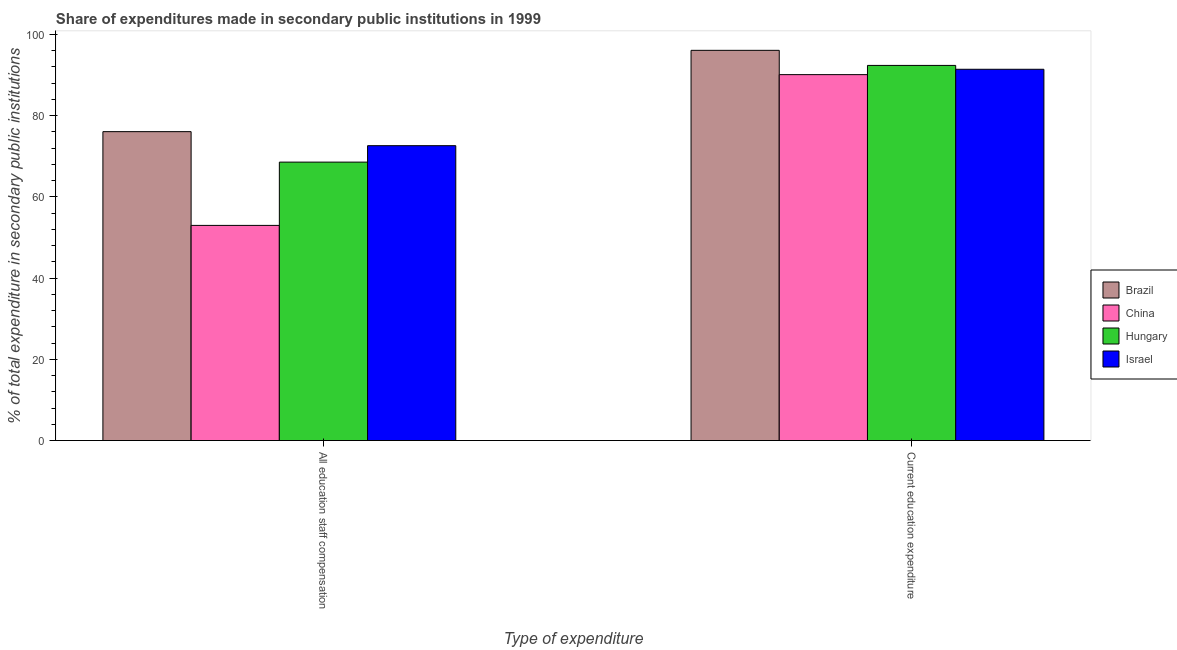How many groups of bars are there?
Your answer should be very brief. 2. How many bars are there on the 2nd tick from the left?
Keep it short and to the point. 4. How many bars are there on the 2nd tick from the right?
Keep it short and to the point. 4. What is the label of the 1st group of bars from the left?
Provide a short and direct response. All education staff compensation. What is the expenditure in education in China?
Provide a succinct answer. 90.11. Across all countries, what is the maximum expenditure in education?
Your answer should be very brief. 96.09. Across all countries, what is the minimum expenditure in education?
Your answer should be compact. 90.11. In which country was the expenditure in staff compensation minimum?
Offer a very short reply. China. What is the total expenditure in staff compensation in the graph?
Provide a short and direct response. 270.23. What is the difference between the expenditure in staff compensation in Israel and that in Brazil?
Make the answer very short. -3.46. What is the difference between the expenditure in staff compensation in Hungary and the expenditure in education in China?
Your answer should be compact. -21.54. What is the average expenditure in staff compensation per country?
Ensure brevity in your answer.  67.56. What is the difference between the expenditure in staff compensation and expenditure in education in Israel?
Offer a very short reply. -18.82. In how many countries, is the expenditure in staff compensation greater than 12 %?
Offer a terse response. 4. What is the ratio of the expenditure in staff compensation in Brazil to that in Hungary?
Your response must be concise. 1.11. What does the 3rd bar from the left in All education staff compensation represents?
Make the answer very short. Hungary. What does the 2nd bar from the right in All education staff compensation represents?
Offer a terse response. Hungary. How many bars are there?
Keep it short and to the point. 8. What is the difference between two consecutive major ticks on the Y-axis?
Provide a succinct answer. 20. Does the graph contain any zero values?
Your response must be concise. No. Where does the legend appear in the graph?
Your response must be concise. Center right. How many legend labels are there?
Make the answer very short. 4. What is the title of the graph?
Provide a succinct answer. Share of expenditures made in secondary public institutions in 1999. What is the label or title of the X-axis?
Offer a very short reply. Type of expenditure. What is the label or title of the Y-axis?
Provide a short and direct response. % of total expenditure in secondary public institutions. What is the % of total expenditure in secondary public institutions in Brazil in All education staff compensation?
Your response must be concise. 76.07. What is the % of total expenditure in secondary public institutions in China in All education staff compensation?
Your response must be concise. 52.98. What is the % of total expenditure in secondary public institutions in Hungary in All education staff compensation?
Offer a terse response. 68.57. What is the % of total expenditure in secondary public institutions of Israel in All education staff compensation?
Your answer should be very brief. 72.61. What is the % of total expenditure in secondary public institutions of Brazil in Current education expenditure?
Offer a very short reply. 96.09. What is the % of total expenditure in secondary public institutions of China in Current education expenditure?
Offer a terse response. 90.11. What is the % of total expenditure in secondary public institutions of Hungary in Current education expenditure?
Give a very brief answer. 92.38. What is the % of total expenditure in secondary public institutions in Israel in Current education expenditure?
Offer a very short reply. 91.43. Across all Type of expenditure, what is the maximum % of total expenditure in secondary public institutions in Brazil?
Give a very brief answer. 96.09. Across all Type of expenditure, what is the maximum % of total expenditure in secondary public institutions of China?
Make the answer very short. 90.11. Across all Type of expenditure, what is the maximum % of total expenditure in secondary public institutions in Hungary?
Your response must be concise. 92.38. Across all Type of expenditure, what is the maximum % of total expenditure in secondary public institutions in Israel?
Your answer should be compact. 91.43. Across all Type of expenditure, what is the minimum % of total expenditure in secondary public institutions of Brazil?
Ensure brevity in your answer.  76.07. Across all Type of expenditure, what is the minimum % of total expenditure in secondary public institutions of China?
Your answer should be very brief. 52.98. Across all Type of expenditure, what is the minimum % of total expenditure in secondary public institutions in Hungary?
Offer a terse response. 68.57. Across all Type of expenditure, what is the minimum % of total expenditure in secondary public institutions in Israel?
Offer a terse response. 72.61. What is the total % of total expenditure in secondary public institutions of Brazil in the graph?
Offer a terse response. 172.16. What is the total % of total expenditure in secondary public institutions in China in the graph?
Your answer should be compact. 143.09. What is the total % of total expenditure in secondary public institutions in Hungary in the graph?
Your answer should be compact. 160.94. What is the total % of total expenditure in secondary public institutions of Israel in the graph?
Keep it short and to the point. 164.04. What is the difference between the % of total expenditure in secondary public institutions of Brazil in All education staff compensation and that in Current education expenditure?
Offer a terse response. -20.02. What is the difference between the % of total expenditure in secondary public institutions in China in All education staff compensation and that in Current education expenditure?
Offer a terse response. -37.12. What is the difference between the % of total expenditure in secondary public institutions of Hungary in All education staff compensation and that in Current education expenditure?
Keep it short and to the point. -23.81. What is the difference between the % of total expenditure in secondary public institutions in Israel in All education staff compensation and that in Current education expenditure?
Offer a very short reply. -18.82. What is the difference between the % of total expenditure in secondary public institutions in Brazil in All education staff compensation and the % of total expenditure in secondary public institutions in China in Current education expenditure?
Your answer should be compact. -14.04. What is the difference between the % of total expenditure in secondary public institutions in Brazil in All education staff compensation and the % of total expenditure in secondary public institutions in Hungary in Current education expenditure?
Offer a terse response. -16.31. What is the difference between the % of total expenditure in secondary public institutions in Brazil in All education staff compensation and the % of total expenditure in secondary public institutions in Israel in Current education expenditure?
Provide a short and direct response. -15.36. What is the difference between the % of total expenditure in secondary public institutions in China in All education staff compensation and the % of total expenditure in secondary public institutions in Hungary in Current education expenditure?
Offer a terse response. -39.39. What is the difference between the % of total expenditure in secondary public institutions of China in All education staff compensation and the % of total expenditure in secondary public institutions of Israel in Current education expenditure?
Keep it short and to the point. -38.44. What is the difference between the % of total expenditure in secondary public institutions in Hungary in All education staff compensation and the % of total expenditure in secondary public institutions in Israel in Current education expenditure?
Provide a short and direct response. -22.86. What is the average % of total expenditure in secondary public institutions of Brazil per Type of expenditure?
Your answer should be compact. 86.08. What is the average % of total expenditure in secondary public institutions in China per Type of expenditure?
Offer a terse response. 71.54. What is the average % of total expenditure in secondary public institutions in Hungary per Type of expenditure?
Provide a short and direct response. 80.47. What is the average % of total expenditure in secondary public institutions of Israel per Type of expenditure?
Ensure brevity in your answer.  82.02. What is the difference between the % of total expenditure in secondary public institutions of Brazil and % of total expenditure in secondary public institutions of China in All education staff compensation?
Provide a succinct answer. 23.08. What is the difference between the % of total expenditure in secondary public institutions in Brazil and % of total expenditure in secondary public institutions in Hungary in All education staff compensation?
Your answer should be very brief. 7.5. What is the difference between the % of total expenditure in secondary public institutions in Brazil and % of total expenditure in secondary public institutions in Israel in All education staff compensation?
Provide a short and direct response. 3.46. What is the difference between the % of total expenditure in secondary public institutions of China and % of total expenditure in secondary public institutions of Hungary in All education staff compensation?
Your response must be concise. -15.58. What is the difference between the % of total expenditure in secondary public institutions of China and % of total expenditure in secondary public institutions of Israel in All education staff compensation?
Give a very brief answer. -19.63. What is the difference between the % of total expenditure in secondary public institutions of Hungary and % of total expenditure in secondary public institutions of Israel in All education staff compensation?
Your response must be concise. -4.05. What is the difference between the % of total expenditure in secondary public institutions of Brazil and % of total expenditure in secondary public institutions of China in Current education expenditure?
Keep it short and to the point. 5.98. What is the difference between the % of total expenditure in secondary public institutions in Brazil and % of total expenditure in secondary public institutions in Hungary in Current education expenditure?
Keep it short and to the point. 3.71. What is the difference between the % of total expenditure in secondary public institutions in Brazil and % of total expenditure in secondary public institutions in Israel in Current education expenditure?
Give a very brief answer. 4.66. What is the difference between the % of total expenditure in secondary public institutions in China and % of total expenditure in secondary public institutions in Hungary in Current education expenditure?
Keep it short and to the point. -2.27. What is the difference between the % of total expenditure in secondary public institutions in China and % of total expenditure in secondary public institutions in Israel in Current education expenditure?
Your answer should be compact. -1.32. What is the difference between the % of total expenditure in secondary public institutions in Hungary and % of total expenditure in secondary public institutions in Israel in Current education expenditure?
Provide a short and direct response. 0.95. What is the ratio of the % of total expenditure in secondary public institutions in Brazil in All education staff compensation to that in Current education expenditure?
Your response must be concise. 0.79. What is the ratio of the % of total expenditure in secondary public institutions in China in All education staff compensation to that in Current education expenditure?
Provide a succinct answer. 0.59. What is the ratio of the % of total expenditure in secondary public institutions in Hungary in All education staff compensation to that in Current education expenditure?
Your answer should be very brief. 0.74. What is the ratio of the % of total expenditure in secondary public institutions of Israel in All education staff compensation to that in Current education expenditure?
Provide a succinct answer. 0.79. What is the difference between the highest and the second highest % of total expenditure in secondary public institutions of Brazil?
Your answer should be very brief. 20.02. What is the difference between the highest and the second highest % of total expenditure in secondary public institutions in China?
Your answer should be compact. 37.12. What is the difference between the highest and the second highest % of total expenditure in secondary public institutions in Hungary?
Make the answer very short. 23.81. What is the difference between the highest and the second highest % of total expenditure in secondary public institutions in Israel?
Give a very brief answer. 18.82. What is the difference between the highest and the lowest % of total expenditure in secondary public institutions of Brazil?
Your answer should be compact. 20.02. What is the difference between the highest and the lowest % of total expenditure in secondary public institutions in China?
Ensure brevity in your answer.  37.12. What is the difference between the highest and the lowest % of total expenditure in secondary public institutions in Hungary?
Your answer should be very brief. 23.81. What is the difference between the highest and the lowest % of total expenditure in secondary public institutions in Israel?
Make the answer very short. 18.82. 